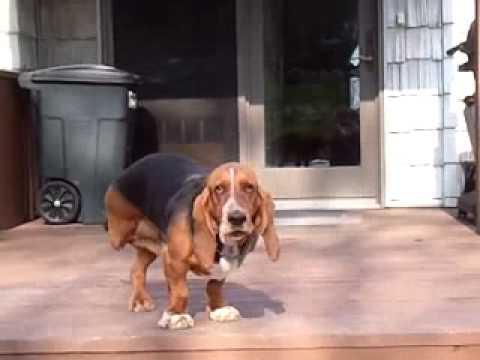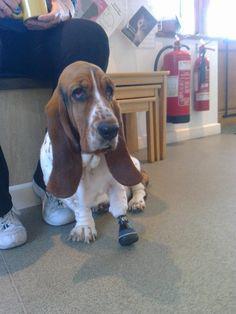The first image is the image on the left, the second image is the image on the right. Assess this claim about the two images: "An image shows a basset hound wearing a front foot prosthetic.". Correct or not? Answer yes or no. Yes. The first image is the image on the left, the second image is the image on the right. Examine the images to the left and right. Is the description "The dog in the left image is looking towards the camera." accurate? Answer yes or no. Yes. 